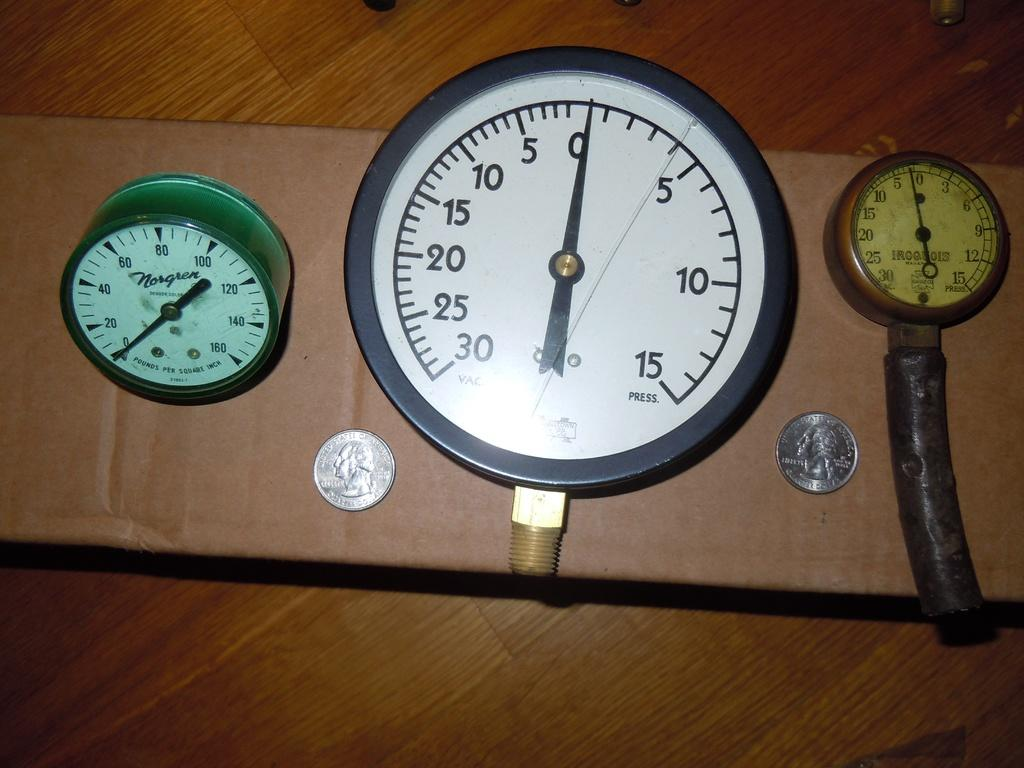What is located in the center of the image? There are meters and coins in the center of the image. What else can be seen in the center of the image besides the meters and coins? There are no other objects visible in the center of the image. What is in the background of the image? There is a wooden board in the background of the image. What type of temper can be seen in the image? There is no temper present in the image; it features meters, coins, and a wooden board. Who is the writer in the image? There is no writer present in the image. 